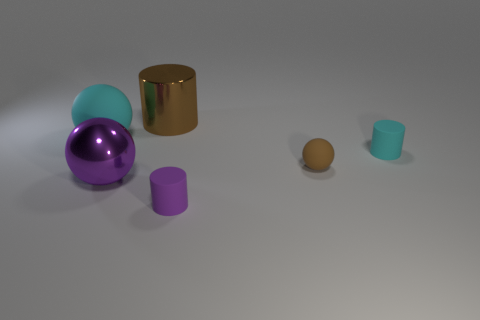Add 2 red matte cylinders. How many objects exist? 8 Add 5 small red metallic cylinders. How many small red metallic cylinders exist? 5 Subtract 1 brown spheres. How many objects are left? 5 Subtract all spheres. Subtract all tiny brown matte objects. How many objects are left? 2 Add 1 small cyan matte cylinders. How many small cyan matte cylinders are left? 2 